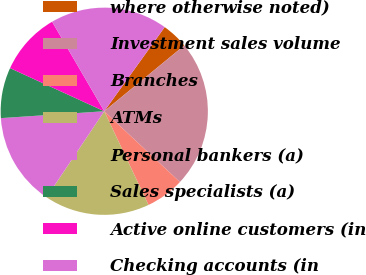Convert chart to OTSL. <chart><loc_0><loc_0><loc_500><loc_500><pie_chart><fcel>where otherwise noted)<fcel>Investment sales volume<fcel>Branches<fcel>ATMs<fcel>Personal bankers (a)<fcel>Sales specialists (a)<fcel>Active online customers (in<fcel>Checking accounts (in<nl><fcel>4.13%<fcel>22.93%<fcel>6.01%<fcel>16.42%<fcel>14.54%<fcel>7.89%<fcel>9.77%<fcel>18.31%<nl></chart> 